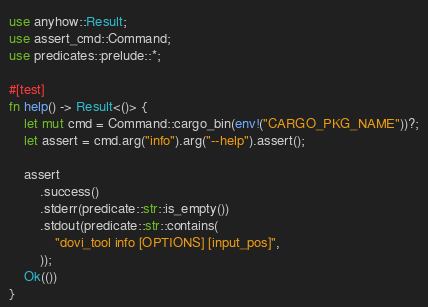<code> <loc_0><loc_0><loc_500><loc_500><_Rust_>use anyhow::Result;
use assert_cmd::Command;
use predicates::prelude::*;

#[test]
fn help() -> Result<()> {
    let mut cmd = Command::cargo_bin(env!("CARGO_PKG_NAME"))?;
    let assert = cmd.arg("info").arg("--help").assert();

    assert
        .success()
        .stderr(predicate::str::is_empty())
        .stdout(predicate::str::contains(
            "dovi_tool info [OPTIONS] [input_pos]",
        ));
    Ok(())
}
</code> 